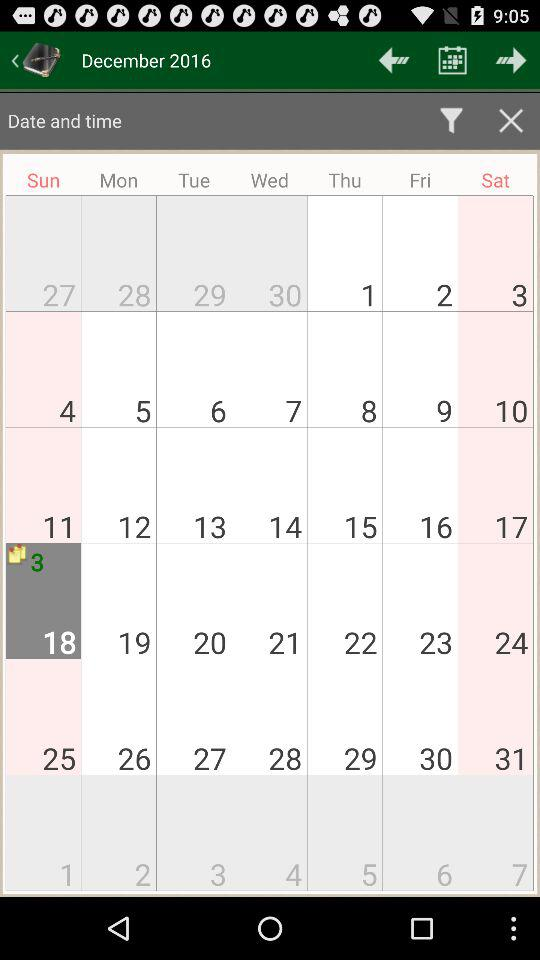What is the day on December 1st? The day is Thursday. 